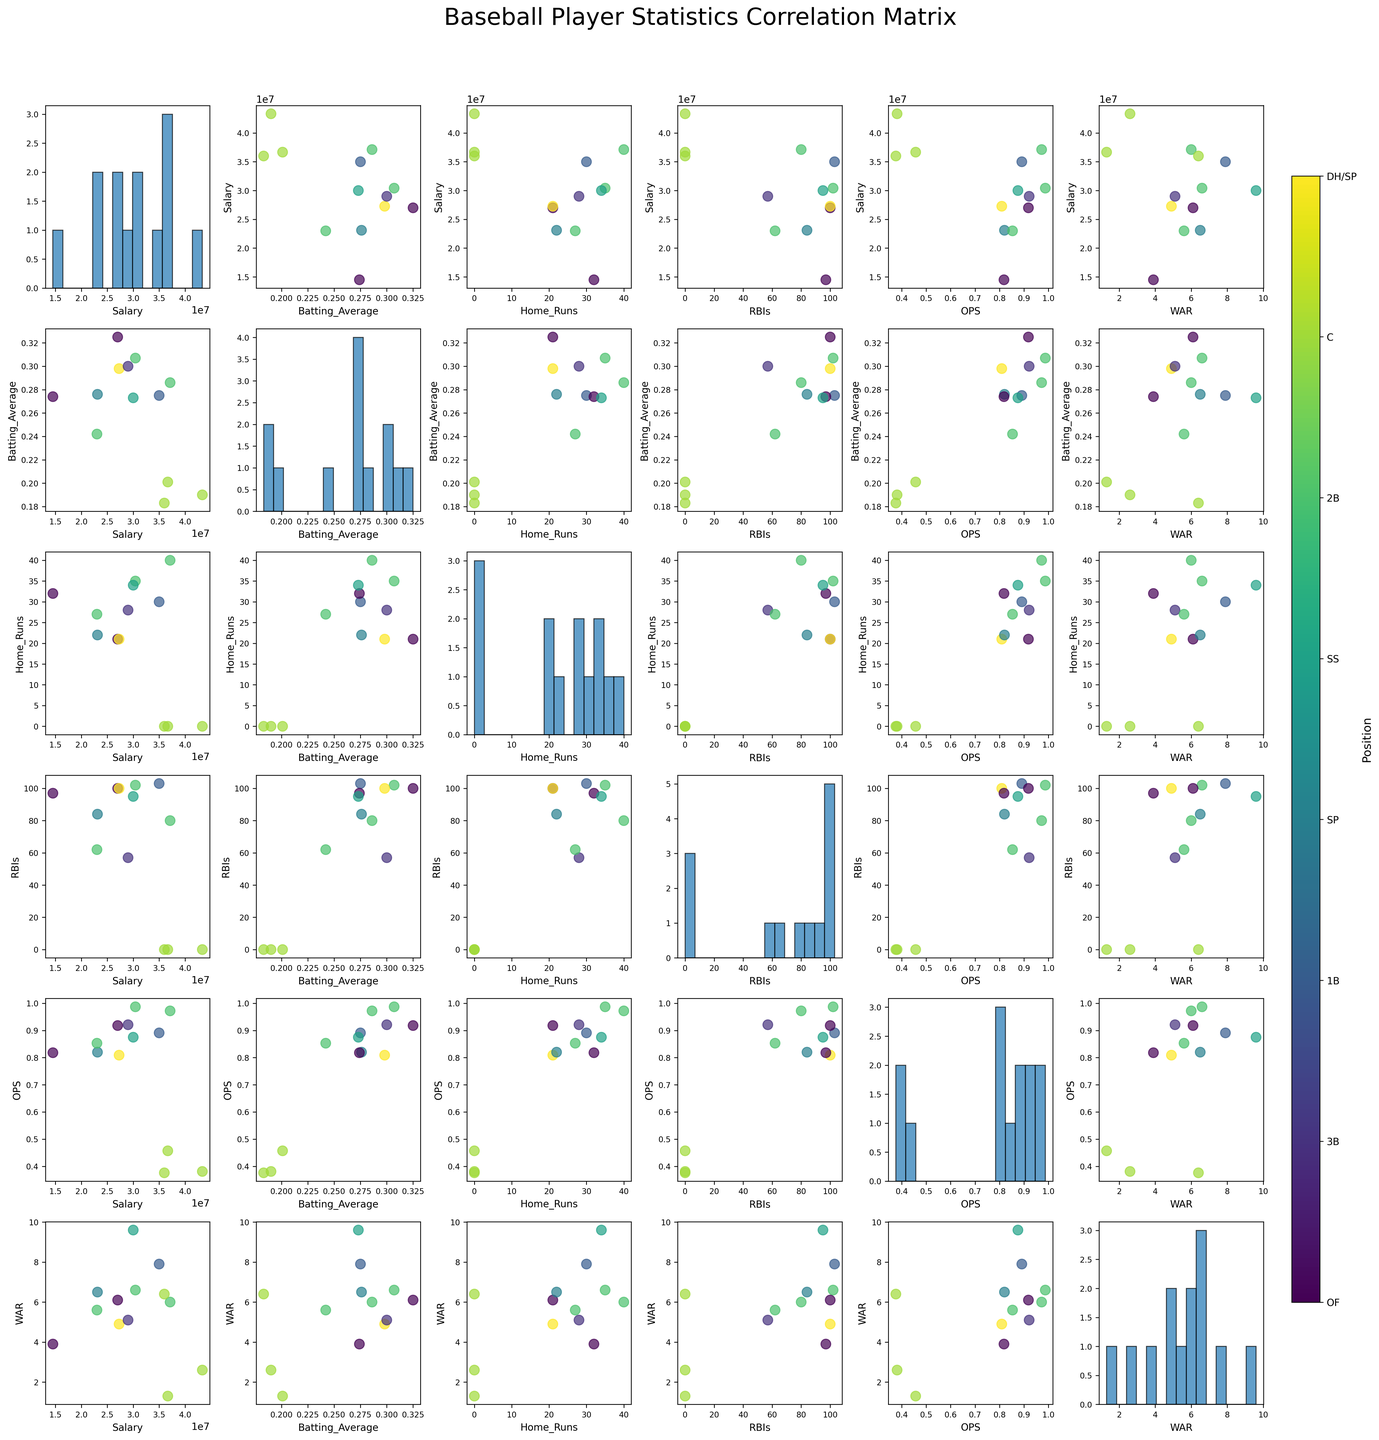How many unique positions are represented in the scatterplot matrix? Identify and count the number of unique positions displayed in the color bar on the right side of the plot.
Answer: 8 What is the title of the scatterplot matrix? The title is displayed at the top center of the scatterplot matrix.
Answer: Baseball Player Statistics Correlation Matrix Which two performance statistics have the highest correlation based on the scatterplot matrix? Compare the scatterplots; the dots forming a straight line are highly correlated. Identify the pair with the most linear relationship. For instance, a high positive correlation will be seen as points forming a straight line from bottom-left to top-right.
Answer: Home Runs and RBIs Are there any significant outliers in the Salary vs. WAR plot? Look for any points that are far away from the rest of the cluster in the Salary vs. WAR scatterplot, typically situated on the extremes of the axes.
Answer: Yes How does Max Scherzer's salary compare to other players in terms of WAR values? Locate Max Scherzer based on his position (SP) and see where his salary and WAR values plot, compare with other data points in the scatterplot of Salary vs. WAR.
Answer: Lower WAR for similar or higher salary On average, which position seems to have the highest OPS values? Look at the OPS histograms and scatter plots grouped by position color, and identify which group generally has the highest OPS values. OF has consistent high-value points.
Answer: OF Is there any player position that has no Home Runs at all? Check the scatterplot of Home Runs against other features. Look for any position where all points are at zero for Home Runs.
Answer: SP Which statistic has the widest range according to its histogram? Compare the histogram spreads for each statistic in the scatterplot matrix to identify which one has the widest distribution.
Answer: Salary Are there players with high RBIs but low WAR values? Look at the scatterplot of RBIs vs. WAR to spot points in the upper left quadrant (high RBIs, low WAR).
Answer: Yes Is there a visible trend between Salary and Batting Average? Examine the scatterplot of Salary vs. Batting Average to identify any upward or downward trend connecting these two variables.
Answer: No significant trend 